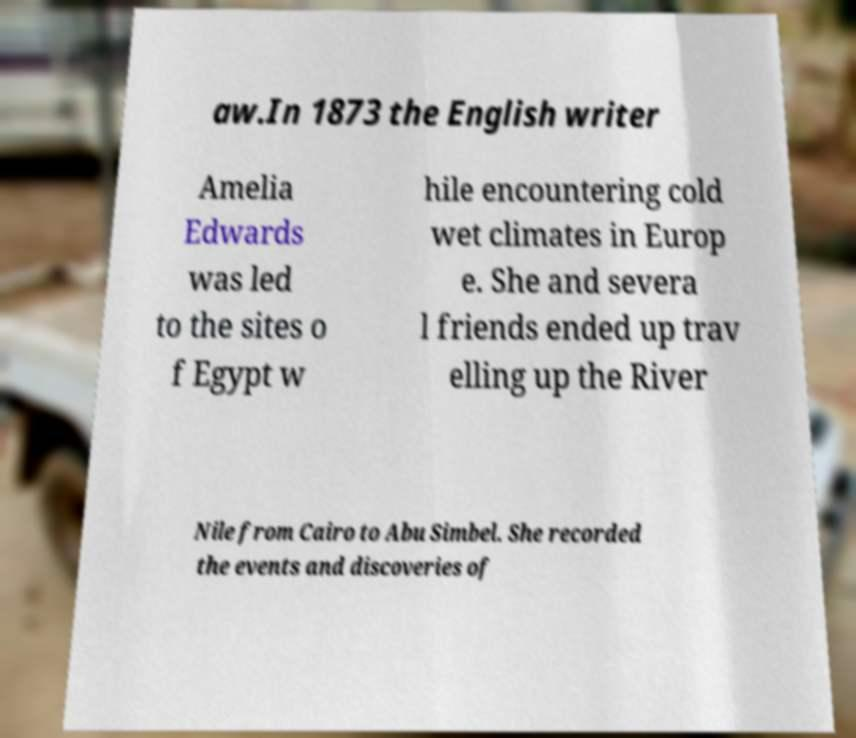Can you read and provide the text displayed in the image?This photo seems to have some interesting text. Can you extract and type it out for me? aw.In 1873 the English writer Amelia Edwards was led to the sites o f Egypt w hile encountering cold wet climates in Europ e. She and severa l friends ended up trav elling up the River Nile from Cairo to Abu Simbel. She recorded the events and discoveries of 